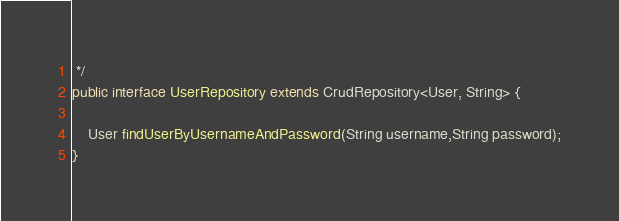<code> <loc_0><loc_0><loc_500><loc_500><_Java_> */
public interface UserRepository extends CrudRepository<User, String> {

	User findUserByUsernameAndPassword(String username,String password);
}
</code> 